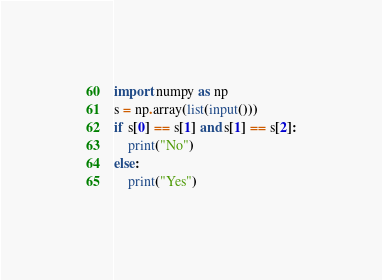Convert code to text. <code><loc_0><loc_0><loc_500><loc_500><_Python_>import numpy as np
s = np.array(list(input()))
if s[0] == s[1] and s[1] == s[2]:
    print("No")
else:
    print("Yes")</code> 